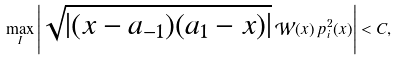<formula> <loc_0><loc_0><loc_500><loc_500>\max _ { I } \left | \sqrt { | ( x - a _ { - 1 } ) ( a _ { 1 } - x ) | } \, \mathcal { W } ( x ) \, { p } _ { i } ^ { 2 } ( x ) \right | < C ,</formula> 